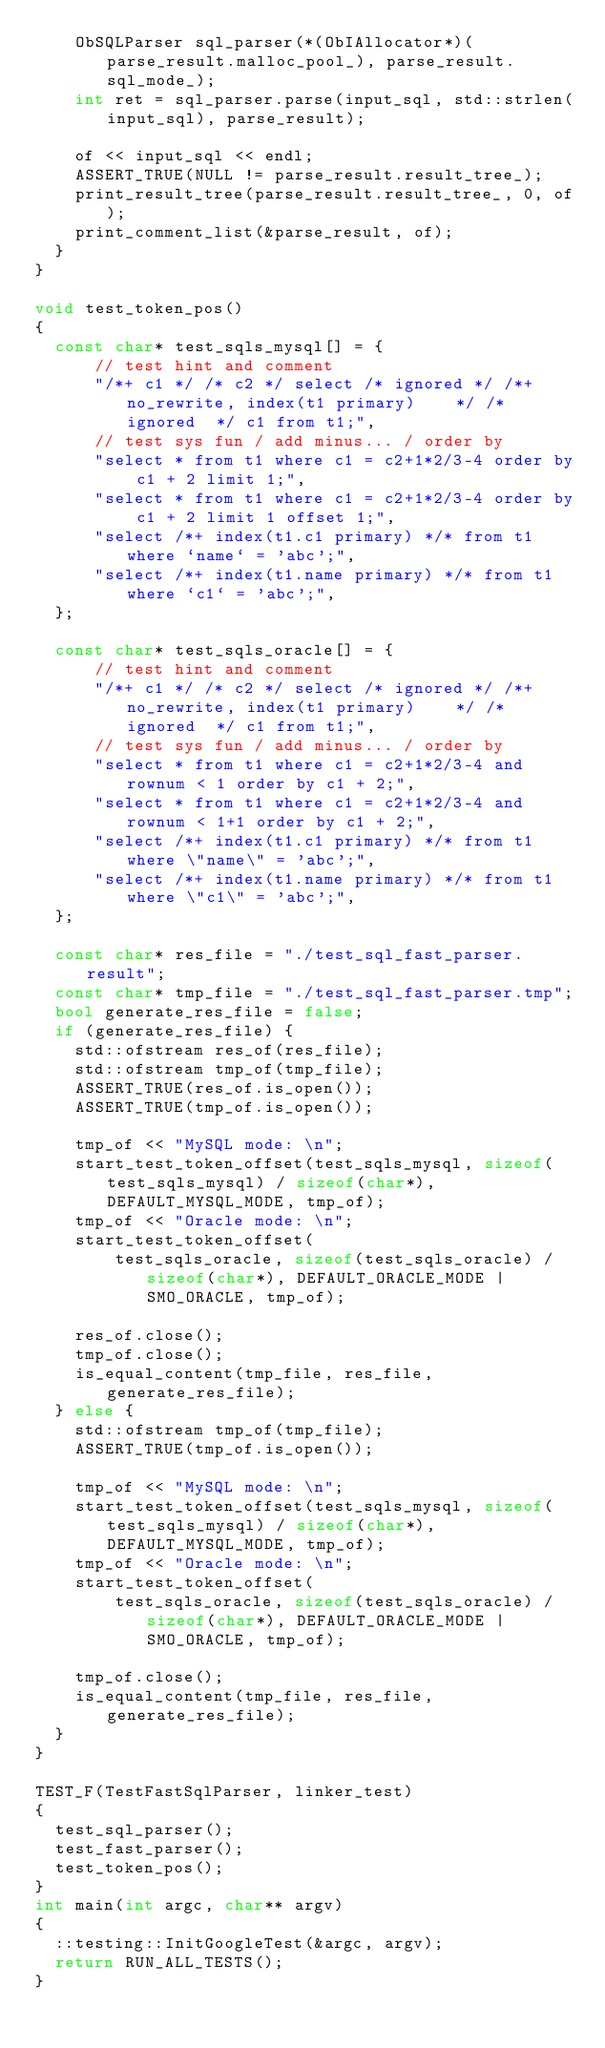<code> <loc_0><loc_0><loc_500><loc_500><_C++_>    ObSQLParser sql_parser(*(ObIAllocator*)(parse_result.malloc_pool_), parse_result.sql_mode_);
    int ret = sql_parser.parse(input_sql, std::strlen(input_sql), parse_result);

    of << input_sql << endl;
    ASSERT_TRUE(NULL != parse_result.result_tree_);
    print_result_tree(parse_result.result_tree_, 0, of);
    print_comment_list(&parse_result, of);
  }
}

void test_token_pos()
{
  const char* test_sqls_mysql[] = {
      // test hint and comment
      "/*+ c1 */ /* c2 */ select /* ignored */ /*+ no_rewrite, index(t1 primary)    */ /* ignored  */ c1 from t1;",
      // test sys fun / add minus... / order by
      "select * from t1 where c1 = c2+1*2/3-4 order by c1 + 2 limit 1;",
      "select * from t1 where c1 = c2+1*2/3-4 order by c1 + 2 limit 1 offset 1;",
      "select /*+ index(t1.c1 primary) */* from t1 where `name` = 'abc';",
      "select /*+ index(t1.name primary) */* from t1 where `c1` = 'abc';",
  };

  const char* test_sqls_oracle[] = {
      // test hint and comment
      "/*+ c1 */ /* c2 */ select /* ignored */ /*+ no_rewrite, index(t1 primary)    */ /* ignored  */ c1 from t1;",
      // test sys fun / add minus... / order by
      "select * from t1 where c1 = c2+1*2/3-4 and rownum < 1 order by c1 + 2;",
      "select * from t1 where c1 = c2+1*2/3-4 and rownum < 1+1 order by c1 + 2;",
      "select /*+ index(t1.c1 primary) */* from t1 where \"name\" = 'abc';",
      "select /*+ index(t1.name primary) */* from t1 where \"c1\" = 'abc';",
  };

  const char* res_file = "./test_sql_fast_parser.result";
  const char* tmp_file = "./test_sql_fast_parser.tmp";
  bool generate_res_file = false;
  if (generate_res_file) {
    std::ofstream res_of(res_file);
    std::ofstream tmp_of(tmp_file);
    ASSERT_TRUE(res_of.is_open());
    ASSERT_TRUE(tmp_of.is_open());

    tmp_of << "MySQL mode: \n";
    start_test_token_offset(test_sqls_mysql, sizeof(test_sqls_mysql) / sizeof(char*), DEFAULT_MYSQL_MODE, tmp_of);
    tmp_of << "Oracle mode: \n";
    start_test_token_offset(
        test_sqls_oracle, sizeof(test_sqls_oracle) / sizeof(char*), DEFAULT_ORACLE_MODE | SMO_ORACLE, tmp_of);

    res_of.close();
    tmp_of.close();
    is_equal_content(tmp_file, res_file, generate_res_file);
  } else {
    std::ofstream tmp_of(tmp_file);
    ASSERT_TRUE(tmp_of.is_open());

    tmp_of << "MySQL mode: \n";
    start_test_token_offset(test_sqls_mysql, sizeof(test_sqls_mysql) / sizeof(char*), DEFAULT_MYSQL_MODE, tmp_of);
    tmp_of << "Oracle mode: \n";
    start_test_token_offset(
        test_sqls_oracle, sizeof(test_sqls_oracle) / sizeof(char*), DEFAULT_ORACLE_MODE | SMO_ORACLE, tmp_of);

    tmp_of.close();
    is_equal_content(tmp_file, res_file, generate_res_file);
  }
}

TEST_F(TestFastSqlParser, linker_test)
{
  test_sql_parser();
  test_fast_parser();
  test_token_pos();
}
int main(int argc, char** argv)
{
  ::testing::InitGoogleTest(&argc, argv);
  return RUN_ALL_TESTS();
}
</code> 